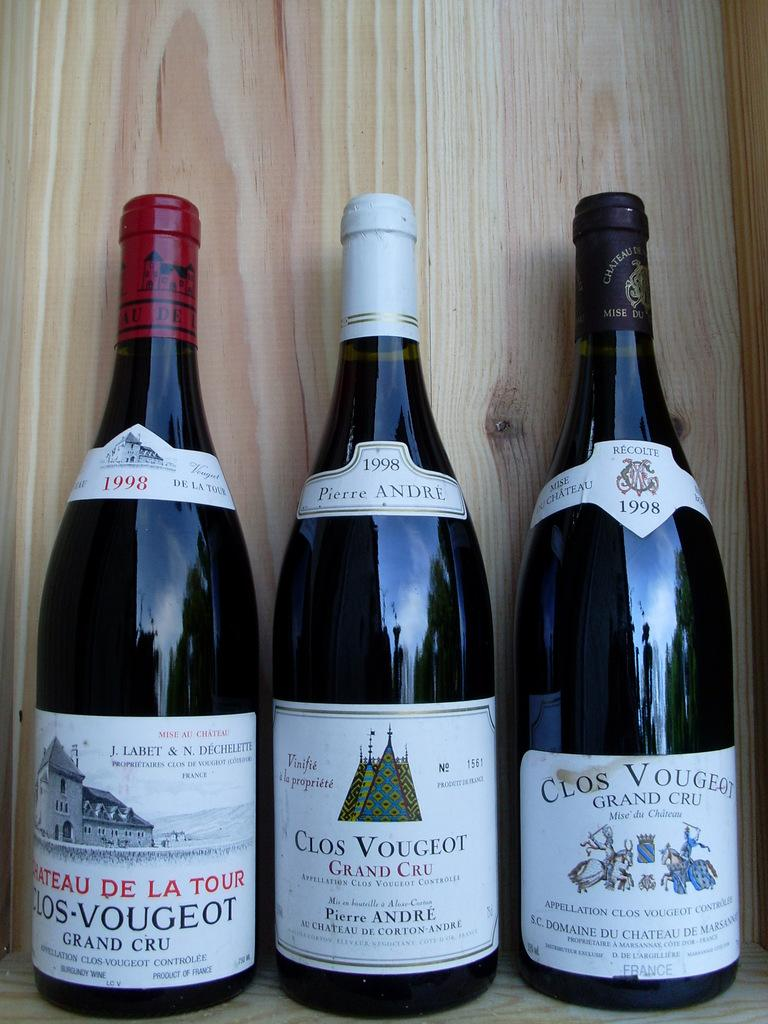<image>
Relay a brief, clear account of the picture shown. Three black bottles with white labels with one of them saying "Clos Vougeot" on it. 